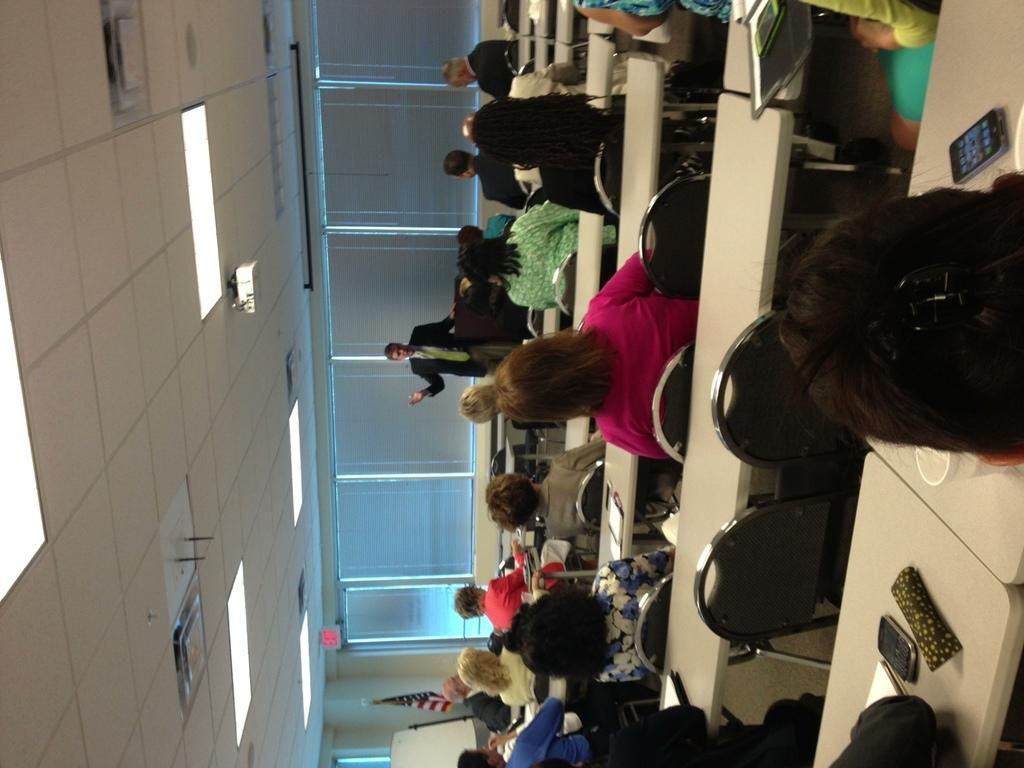How would you summarize this image in a sentence or two? In the picture we can see the people sitting near the tables and in front of them, we can see a man standing and explaining something, he is in a blazer, tie and shirt and behind him we can see the windows with curtains to it and besides the window we can see the part of the board and a flag to the pole and to the ceiling we can see the lights. 